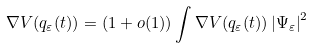Convert formula to latex. <formula><loc_0><loc_0><loc_500><loc_500>\nabla V ( q _ { \varepsilon } ( t ) ) = \left ( 1 + o ( 1 ) \right ) \int \nabla V ( q _ { \varepsilon } ( t ) ) \left | \Psi _ { \varepsilon } \right | ^ { 2 }</formula> 